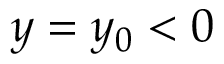Convert formula to latex. <formula><loc_0><loc_0><loc_500><loc_500>y = y _ { 0 } < 0</formula> 